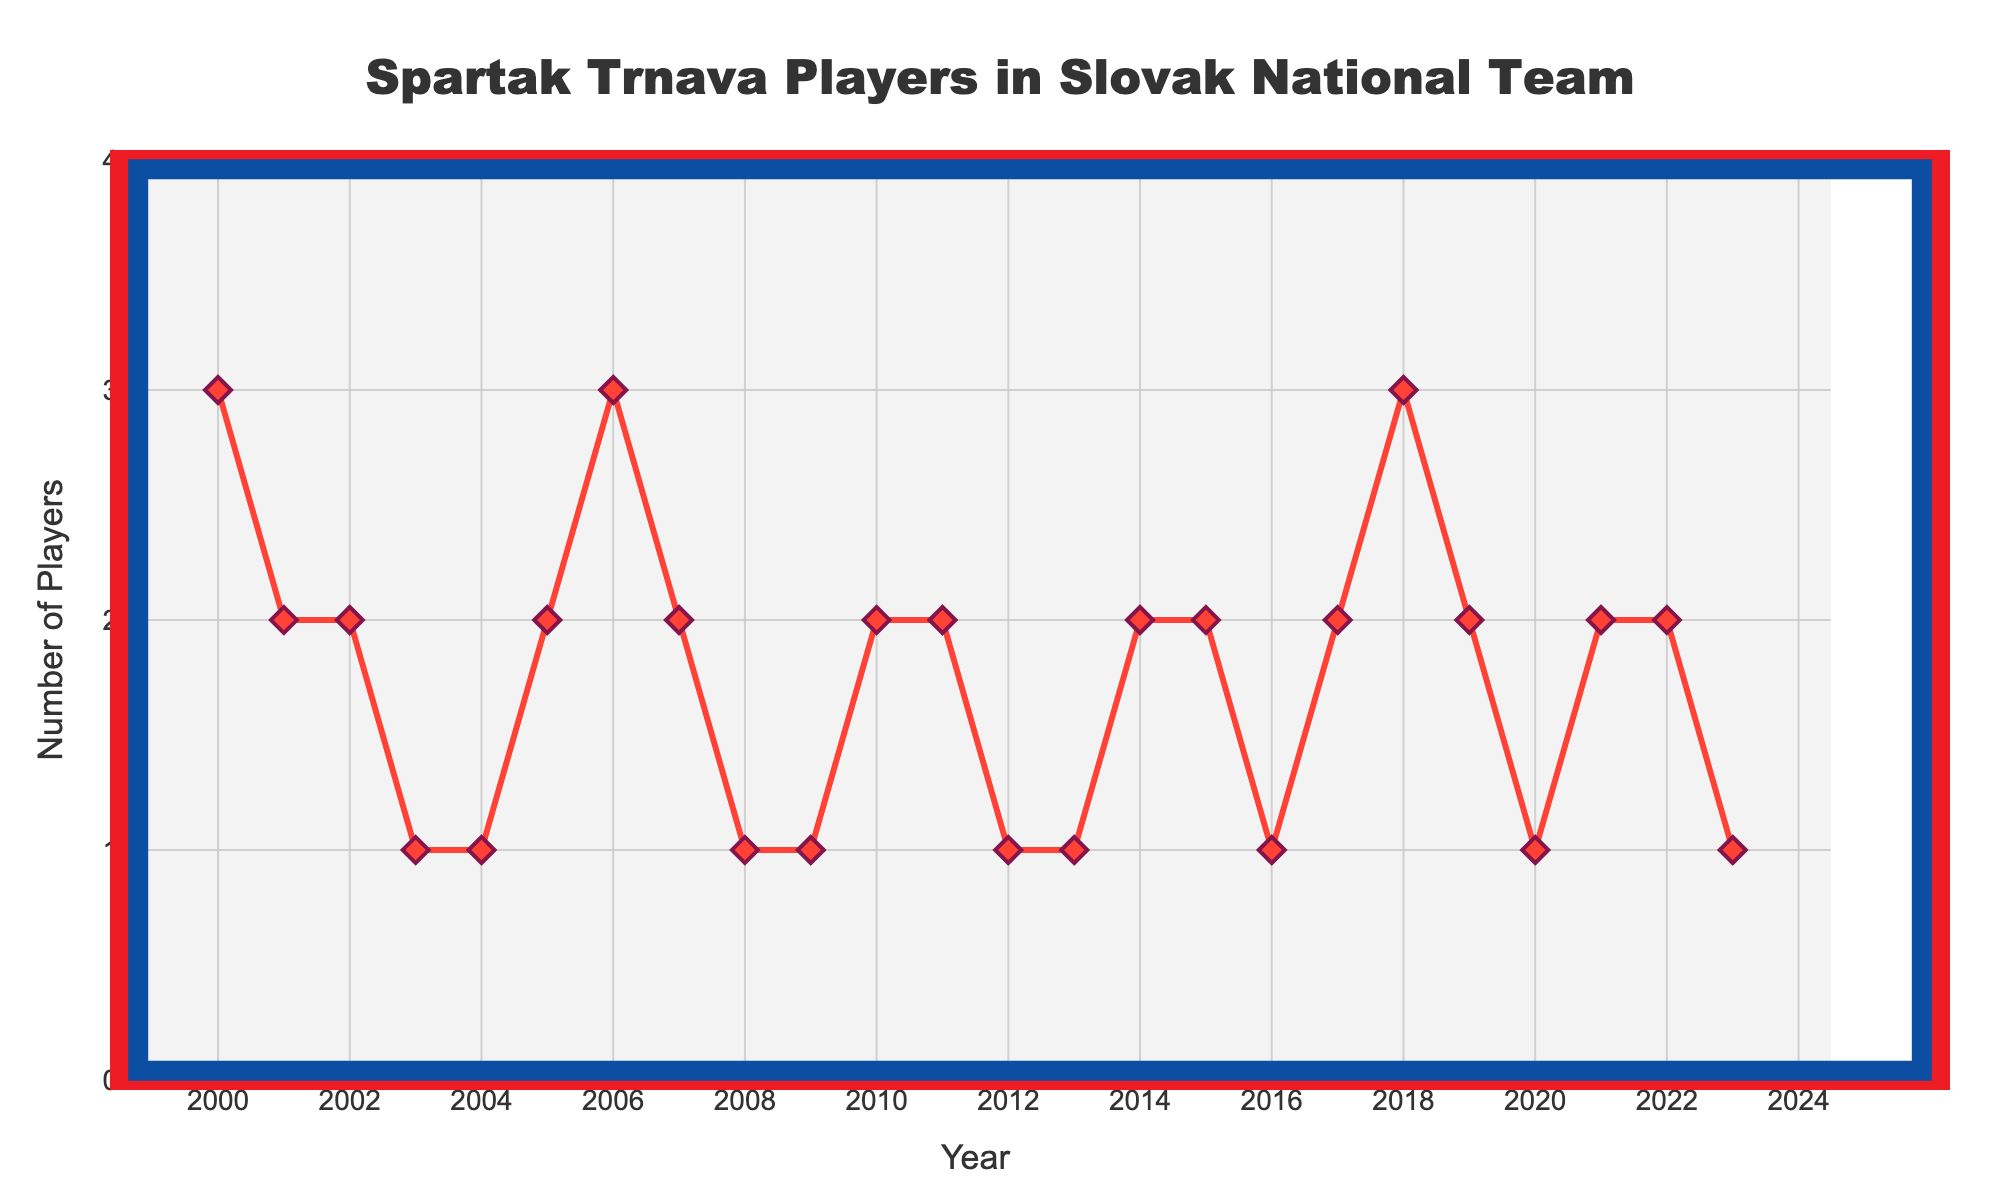Is there any year where Spartak Trnava had the maximum number of players in the Slovak national team? By looking at the vertical height of the lines and markers, 2000, 2006, and 2018 stand out as the highest points on the chart, indicating three players in each of those years.
Answer: 2000, 2006, 2018 What is the total number of players sent to the national team from 2000 to 2004? Sum the values of Spartak Trnava players from 2000 to 2004: 3 (2000) + 2 (2001) + 2 (2002) + 1 (2003) + 1 (2004) = 9.
Answer: 9 How many years saw exactly one player from Spartak Trnava in the Slovak national team? Identify the years where the value is 1 by counting the markers at the level of 1 on the vertical axis. These years are 2003, 2004, 2008, 2009, 2012, 2013, 2016, 2020, and 2023. Count these years.
Answer: 9 What is the difference in the number of players between 2000 and 2023? Compare the number of players in 2000 (3 players) to 2023 (1 player). Calculate the difference: 3 - 1 = 2.
Answer: 2 Which years have consecutive decreases in the number of players? Identify pairs of years where the value decreases from one year to the next. Examples are 2000 to 2001, 2006 to 2007, and 2018 to 2019.
Answer: 2000-2001, 2006-2007, 2018-2019 What is the least number of players sent to the Slovak national team in any given year? The smallest vertical height on the line chart corresponds to 1 player, which occurs multiple times.
Answer: 1 How many times did Spartak Trnava send more than two players to the national team? Identify and count the points where the vertical line exceeds the level of 2. These occur in 2000, 2006, and 2018, resulting in three occurrences.
Answer: 3 What is the sum of the number of players sent to the national team in the years 2017, 2018, and 2019? Add the values for these years: 2 (2017) + 3 (2018) + 2 (2019) = 7.
Answer: 7 In which year following 2010 did Spartak Trnava see their lowest number of players in the national team? After 2010, the lowest number of players is 1, which happens in 2012, 2013, 2016, 2020, and 2023. The first instance is 2012.
Answer: 2012 When was the last time Spartak Trnava had an increase in the number of players? Look for the last instance in the timeline where the vertical marker height increases from one year to the next. This last occurred between 2021 (2 players) and 2022 (2 players), prior to 2023's decrease to 1 player. Therefore, the last actual increase came between 2018 and 2019, considering subsequent years have consistent or reduced counts.
Answer: 2022 